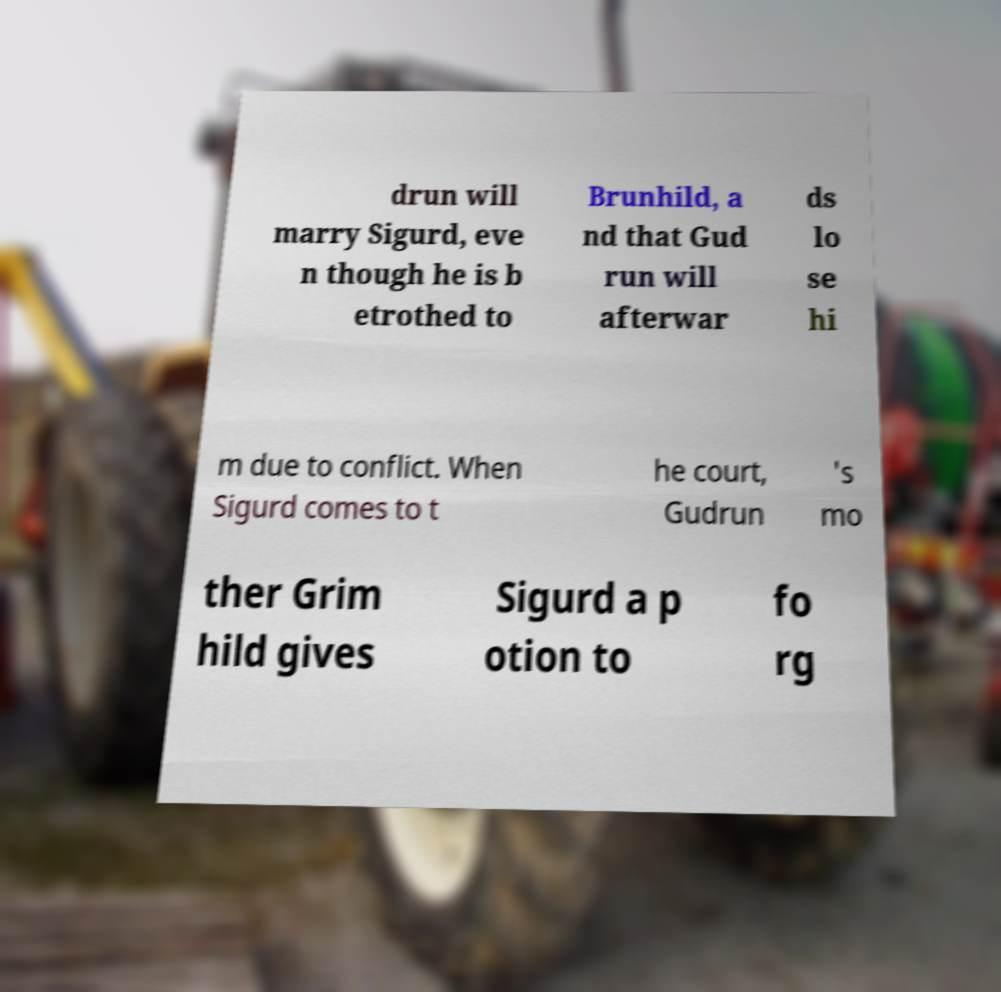Could you extract and type out the text from this image? drun will marry Sigurd, eve n though he is b etrothed to Brunhild, a nd that Gud run will afterwar ds lo se hi m due to conflict. When Sigurd comes to t he court, Gudrun 's mo ther Grim hild gives Sigurd a p otion to fo rg 